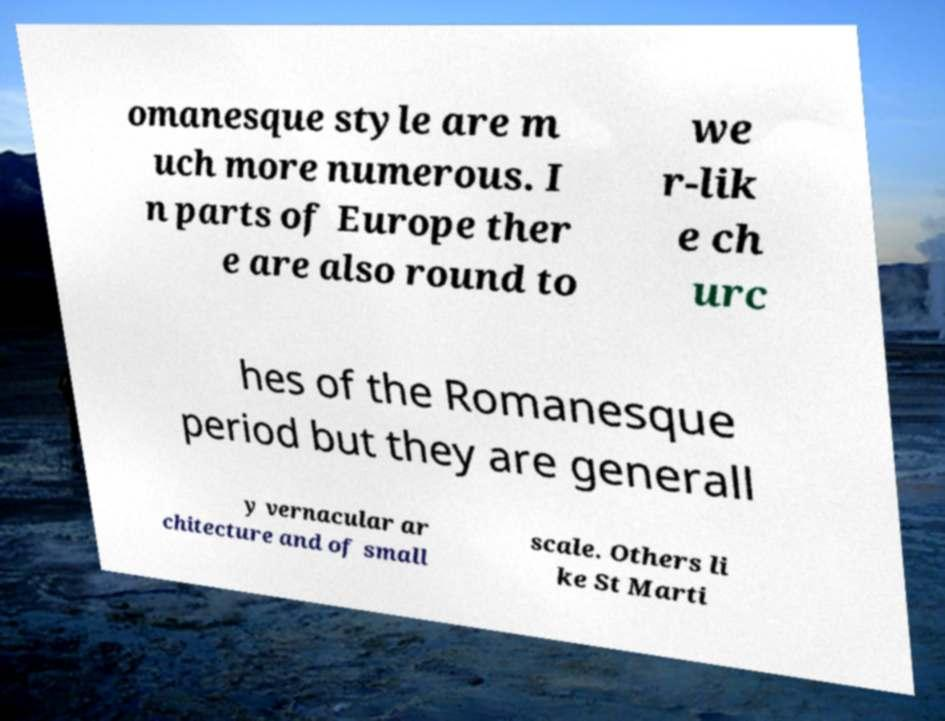Could you assist in decoding the text presented in this image and type it out clearly? omanesque style are m uch more numerous. I n parts of Europe ther e are also round to we r-lik e ch urc hes of the Romanesque period but they are generall y vernacular ar chitecture and of small scale. Others li ke St Marti 